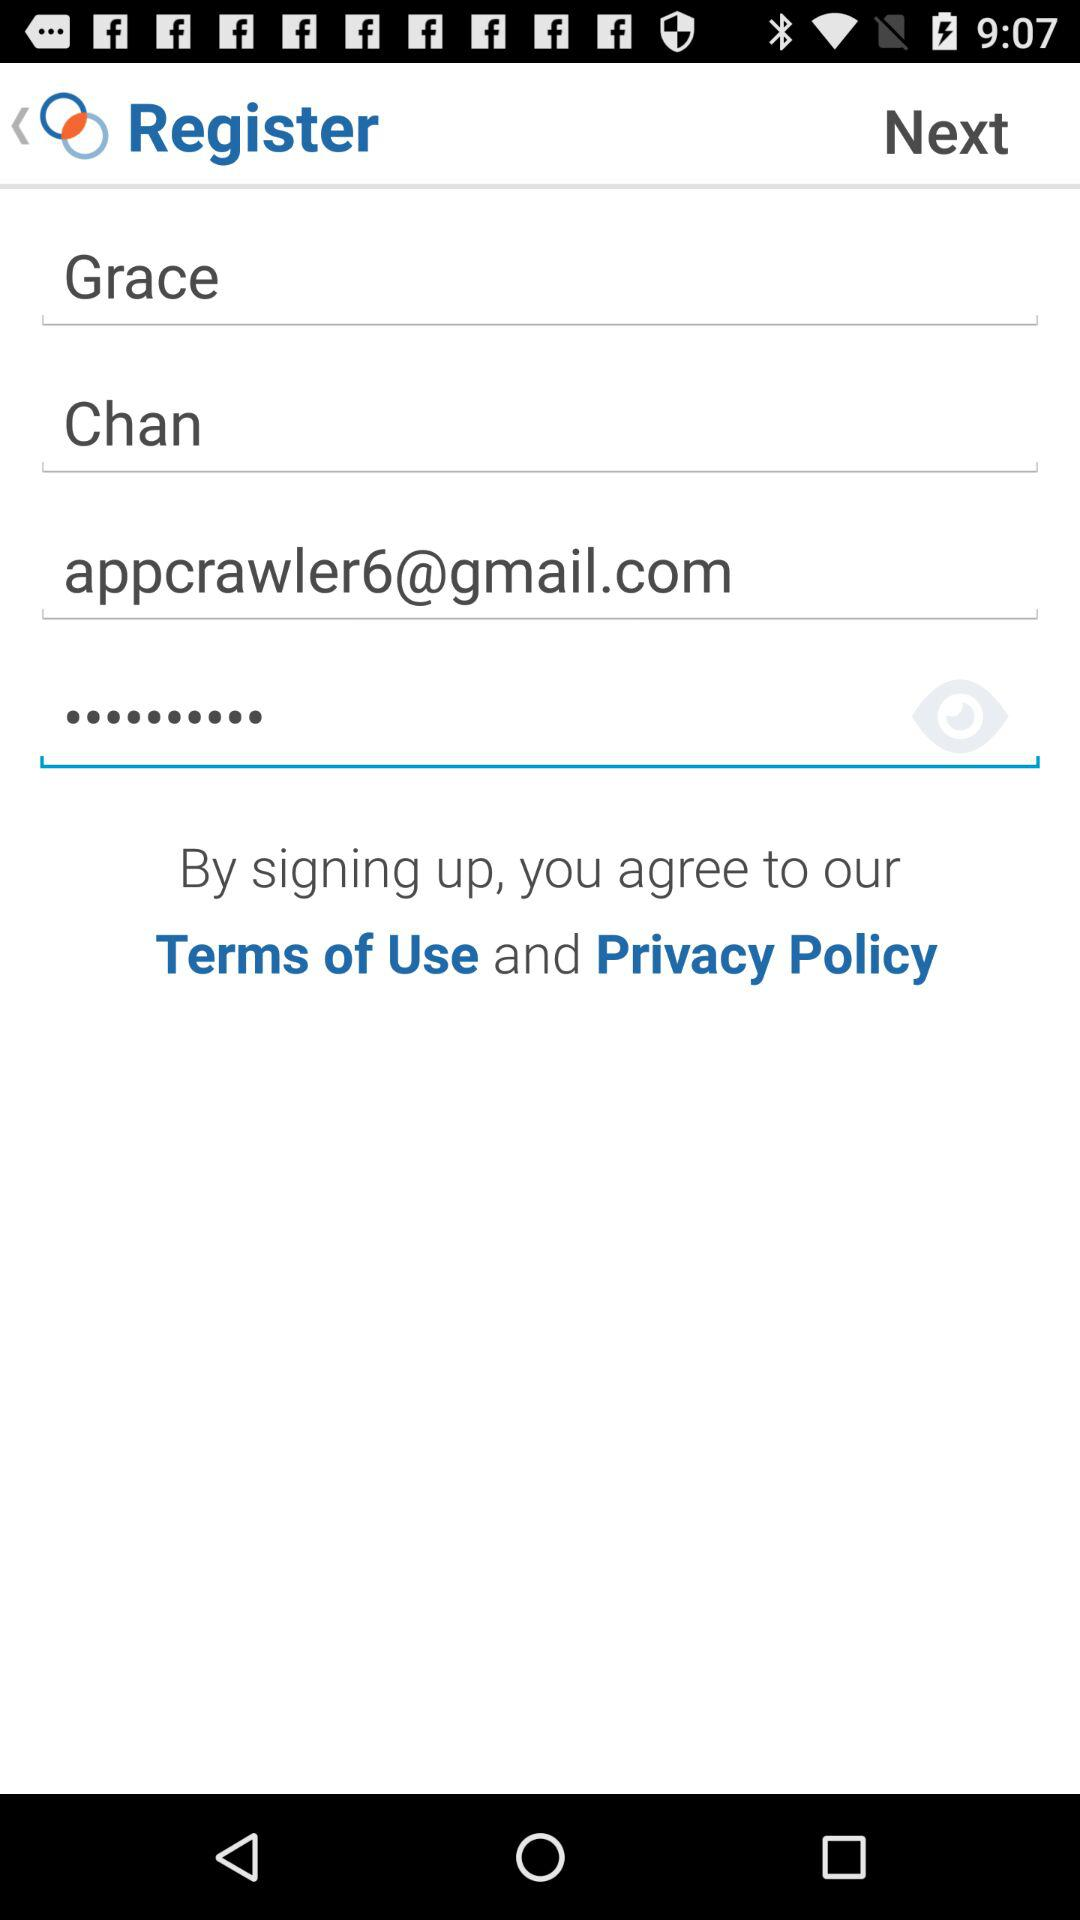What is the user name? The user name is Grace Chan. 